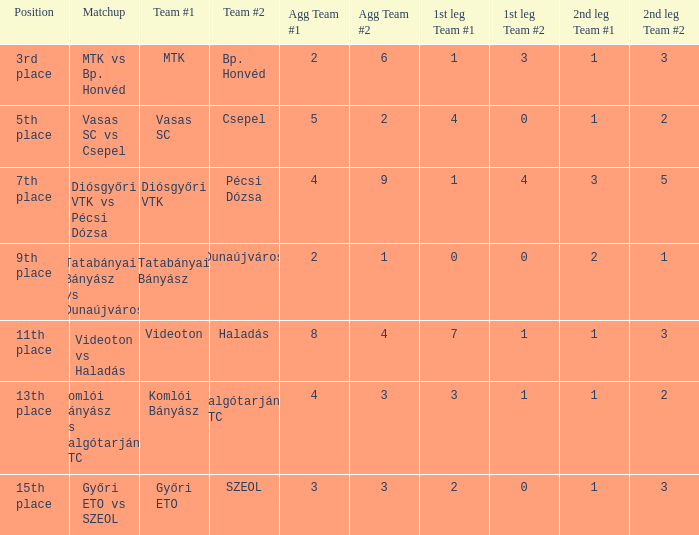What is the team #1 with an 11th place position? Videoton. 